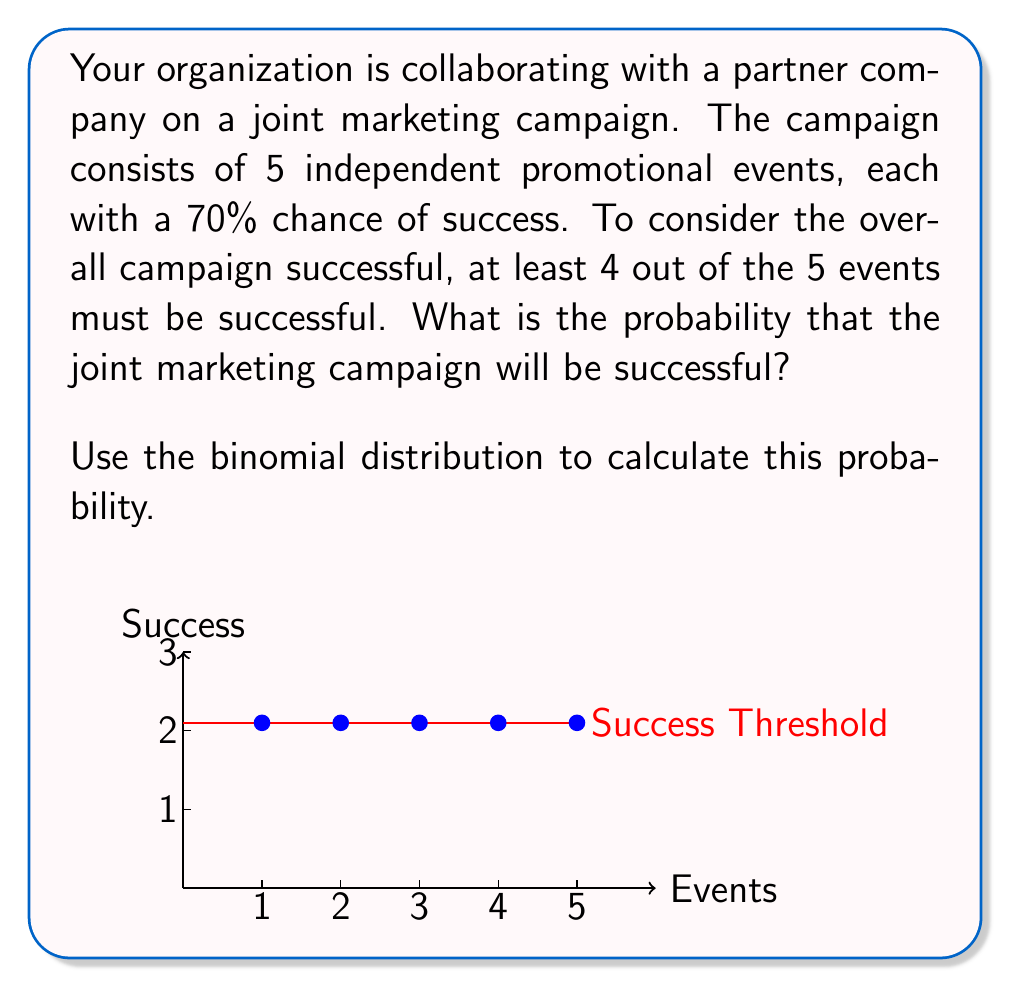Could you help me with this problem? Let's approach this step-by-step using the binomial distribution:

1) We can model this scenario using a binomial distribution because:
   - There are a fixed number of trials (n = 5 events)
   - Each trial has two possible outcomes (success or failure)
   - The probability of success is the same for each trial (p = 0.7)
   - The trials are independent

2) We need to find P(X ≥ 4), where X is the number of successful events.

3) The probability mass function for a binomial distribution is:

   $$P(X = k) = \binom{n}{k} p^k (1-p)^{n-k}$$

   where n is the number of trials, k is the number of successes, and p is the probability of success on each trial.

4) We need to calculate P(X = 4) + P(X = 5):

   P(X = 4) = $\binom{5}{4} (0.7)^4 (0.3)^1$
             = $5 \cdot 0.7^4 \cdot 0.3$
             = $5 \cdot 0.2401 \cdot 0.3$
             = 0.36015

   P(X = 5) = $\binom{5}{5} (0.7)^5 (0.3)^0$
             = $1 \cdot 0.7^5$
             = 0.16807

5) The total probability is:
   P(X ≥ 4) = P(X = 4) + P(X = 5)
            = 0.36015 + 0.16807
            = 0.52822

6) Therefore, the probability that the joint marketing campaign will be successful is approximately 0.52822 or 52.822%.
Answer: 0.52822 or 52.822% 